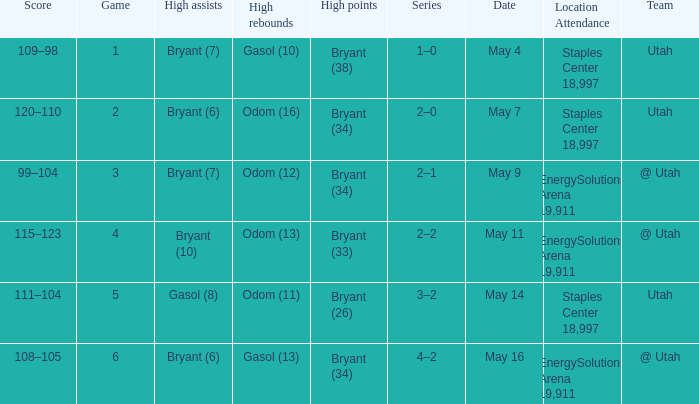What is the Series with a High rebounds with gasol (10)? 1–0. I'm looking to parse the entire table for insights. Could you assist me with that? {'header': ['Score', 'Game', 'High assists', 'High rebounds', 'High points', 'Series', 'Date', 'Location Attendance', 'Team'], 'rows': [['109–98', '1', 'Bryant (7)', 'Gasol (10)', 'Bryant (38)', '1–0', 'May 4', 'Staples Center 18,997', 'Utah'], ['120–110', '2', 'Bryant (6)', 'Odom (16)', 'Bryant (34)', '2–0', 'May 7', 'Staples Center 18,997', 'Utah'], ['99–104', '3', 'Bryant (7)', 'Odom (12)', 'Bryant (34)', '2–1', 'May 9', 'EnergySolutions Arena 19,911', '@ Utah'], ['115–123', '4', 'Bryant (10)', 'Odom (13)', 'Bryant (33)', '2–2', 'May 11', 'EnergySolutions Arena 19,911', '@ Utah'], ['111–104', '5', 'Gasol (8)', 'Odom (11)', 'Bryant (26)', '3–2', 'May 14', 'Staples Center 18,997', 'Utah'], ['108–105', '6', 'Bryant (6)', 'Gasol (13)', 'Bryant (34)', '4–2', 'May 16', 'EnergySolutions Arena 19,911', '@ Utah']]} 